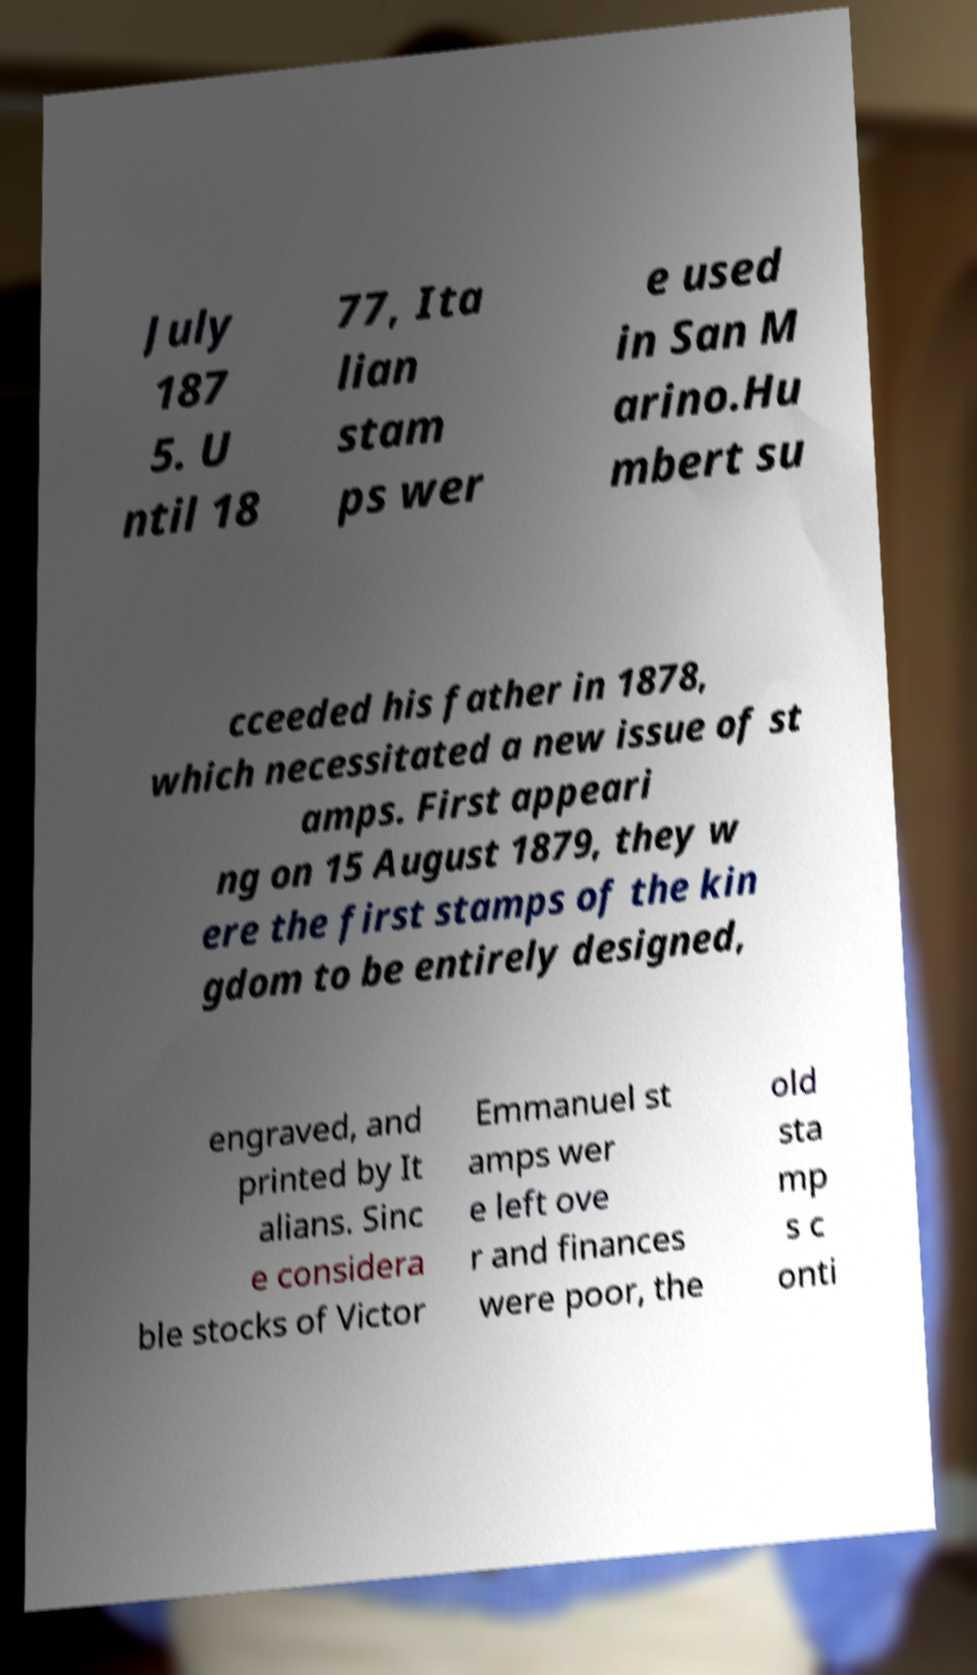I need the written content from this picture converted into text. Can you do that? July 187 5. U ntil 18 77, Ita lian stam ps wer e used in San M arino.Hu mbert su cceeded his father in 1878, which necessitated a new issue of st amps. First appeari ng on 15 August 1879, they w ere the first stamps of the kin gdom to be entirely designed, engraved, and printed by It alians. Sinc e considera ble stocks of Victor Emmanuel st amps wer e left ove r and finances were poor, the old sta mp s c onti 